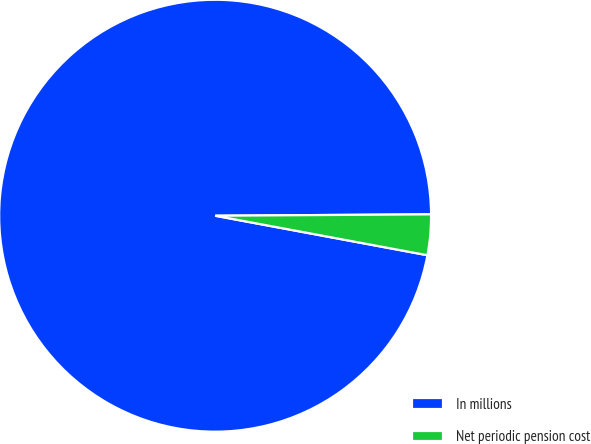Convert chart to OTSL. <chart><loc_0><loc_0><loc_500><loc_500><pie_chart><fcel>In millions<fcel>Net periodic pension cost<nl><fcel>96.97%<fcel>3.03%<nl></chart> 